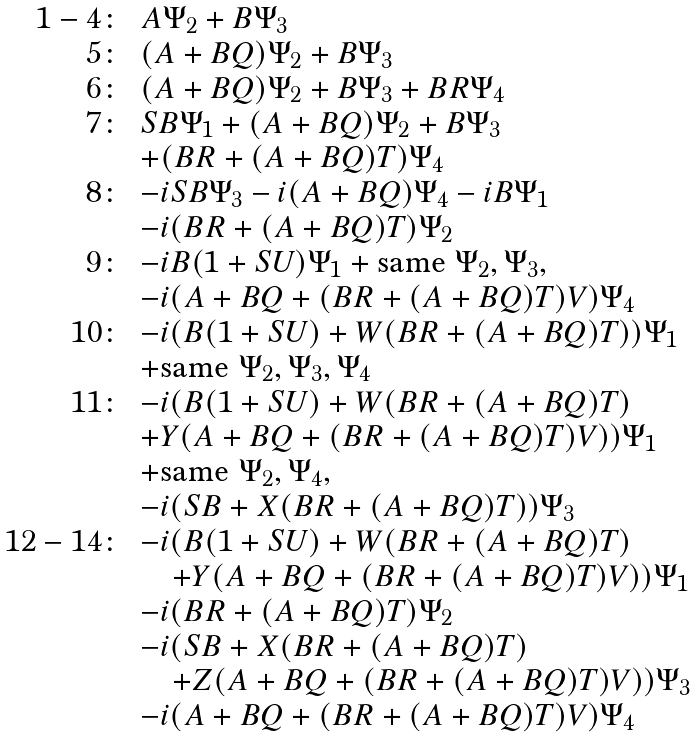Convert formula to latex. <formula><loc_0><loc_0><loc_500><loc_500>\begin{array} { r l } 1 - 4 \colon & A \Psi _ { 2 } + B \Psi _ { 3 } \\ 5 \colon & ( A + B Q ) \Psi _ { 2 } + B \Psi _ { 3 } \\ 6 \colon & ( A + B Q ) \Psi _ { 2 } + B \Psi _ { 3 } + B R \Psi _ { 4 } \\ 7 \colon & S B \Psi _ { 1 } + ( A + B Q ) \Psi _ { 2 } + B \Psi _ { 3 } \\ & + ( B R + ( A + B Q ) T ) \Psi _ { 4 } \\ 8 \colon & - i S B \Psi _ { 3 } - i ( A + B Q ) \Psi _ { 4 } - i B \Psi _ { 1 } \\ & - i ( B R + ( A + B Q ) T ) \Psi _ { 2 } \\ 9 \colon & - i B ( 1 + S U ) \Psi _ { 1 } + \text {same} \ \Psi _ { 2 } , \Psi _ { 3 } , \\ & - i ( A + B Q + ( B R + ( A + B Q ) T ) V ) \Psi _ { 4 } \\ 1 0 \colon & - i ( B ( 1 + S U ) + W ( B R + ( A + B Q ) T ) ) \Psi _ { 1 } \\ & + \text {same} \ \Psi _ { 2 } , \Psi _ { 3 } , \Psi _ { 4 } \\ 1 1 \colon & - i ( B ( 1 + S U ) + W ( B R + ( A + B Q ) T ) \\ & + Y ( A + B Q + ( B R + ( A + B Q ) T ) V ) ) \Psi _ { 1 } \\ & + \text {same} \ \Psi _ { 2 } , \Psi _ { 4 } , \\ & - i ( S B + X ( B R + ( A + B Q ) T ) ) \Psi _ { 3 } \\ 1 2 - 1 4 \colon & - i ( B ( 1 + S U ) + W ( B R + ( A + B Q ) T ) \\ & \quad + Y ( A + B Q + ( B R + ( A + B Q ) T ) V ) ) \Psi _ { 1 } \\ & - i ( B R + ( A + B Q ) T ) \Psi _ { 2 } \\ & - i ( S B + X ( B R + ( A + B Q ) T ) \\ & \quad + Z ( A + B Q + ( B R + ( A + B Q ) T ) V ) ) \Psi _ { 3 } \\ & - i ( A + B Q + ( B R + ( A + B Q ) T ) V ) \Psi _ { 4 } \end{array}</formula> 